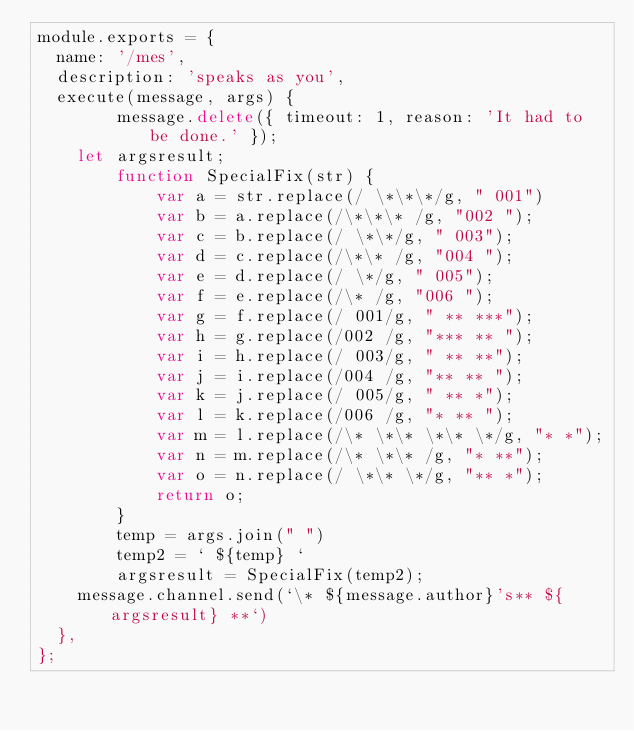Convert code to text. <code><loc_0><loc_0><loc_500><loc_500><_JavaScript_>module.exports = {
	name: '/mes',
	description: 'speaks as you',
	execute(message, args) {
        message.delete({ timeout: 1, reason: 'It had to be done.' });
		let argsresult;
        function SpecialFix(str) {
            var a = str.replace(/ \*\*\*/g, " 001")
            var b = a.replace(/\*\*\* /g, "002 ");
            var c = b.replace(/ \*\*/g, " 003");
            var d = c.replace(/\*\* /g, "004 ");
            var e = d.replace(/ \*/g, " 005");
            var f = e.replace(/\* /g, "006 ");
            var g = f.replace(/ 001/g, " ** ***");
            var h = g.replace(/002 /g, "*** ** ");
            var i = h.replace(/ 003/g, " ** **");
            var j = i.replace(/004 /g, "** ** ");
            var k = j.replace(/ 005/g, " ** *");
            var l = k.replace(/006 /g, "* ** ");
            var m = l.replace(/\* \*\* \*\* \*/g, "* *");
            var n = m.replace(/\* \*\* /g, "* **");
            var o = n.replace(/ \*\* \*/g, "** *");
            return o;
        }
        temp = args.join(" ")
        temp2 = ` ${temp} `
        argsresult = SpecialFix(temp2);
		message.channel.send(`\* ${message.author}'s** ${argsresult} **`)
	},
};</code> 